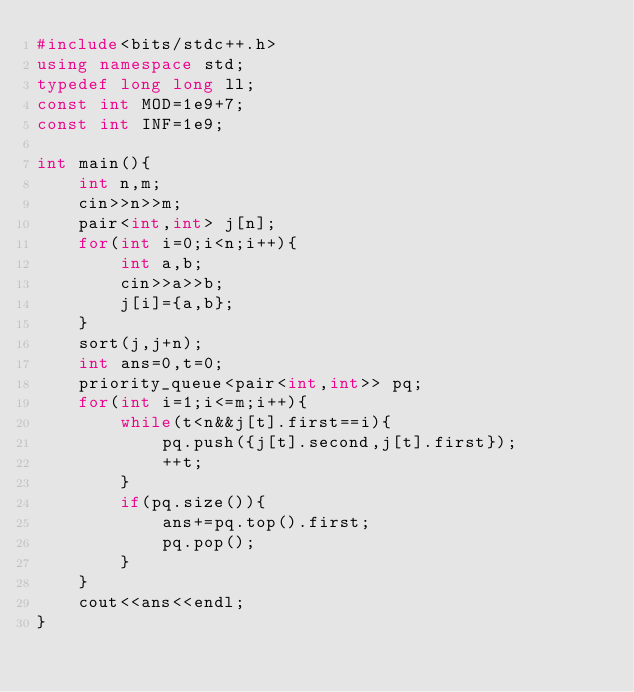Convert code to text. <code><loc_0><loc_0><loc_500><loc_500><_C++_>#include<bits/stdc++.h>
using namespace std;
typedef long long ll;
const int MOD=1e9+7;
const int INF=1e9;

int main(){
    int n,m;
    cin>>n>>m;
    pair<int,int> j[n];
    for(int i=0;i<n;i++){
        int a,b;
        cin>>a>>b;
        j[i]={a,b};
    }
    sort(j,j+n);
    int ans=0,t=0;
    priority_queue<pair<int,int>> pq;
    for(int i=1;i<=m;i++){
        while(t<n&&j[t].first==i){
            pq.push({j[t].second,j[t].first});
            ++t;
        }
        if(pq.size()){
            ans+=pq.top().first;
            pq.pop();
        }
    }
    cout<<ans<<endl;
}
</code> 